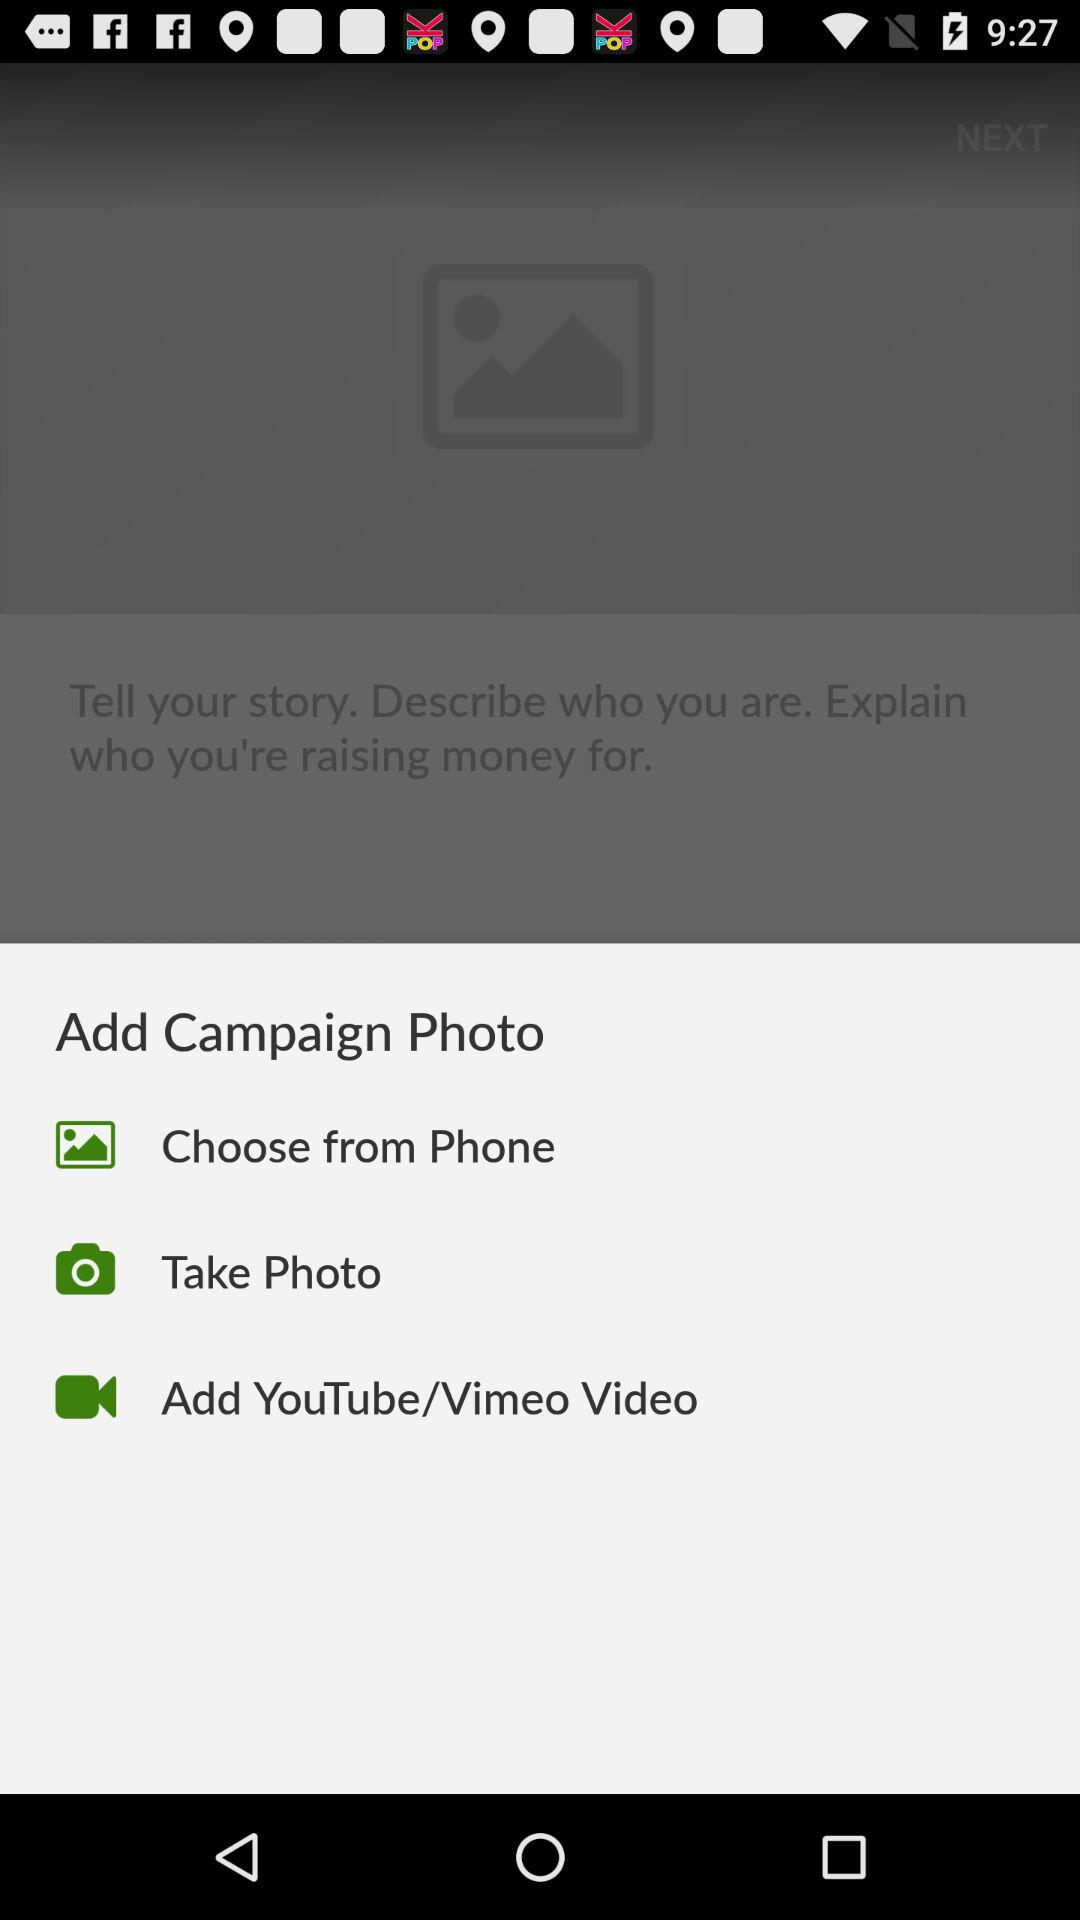How many options are there to add a campaign photo?
Answer the question using a single word or phrase. 3 